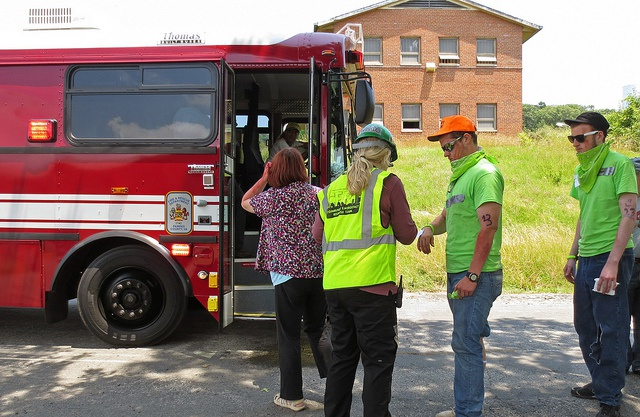Describe the objects in this image and their specific colors. I can see bus in white, black, gray, and brown tones, people in white, black, lime, maroon, and gray tones, people in white, black, lightgreen, green, and gray tones, people in white, blue, green, and gray tones, and people in white, black, maroon, gray, and brown tones in this image. 